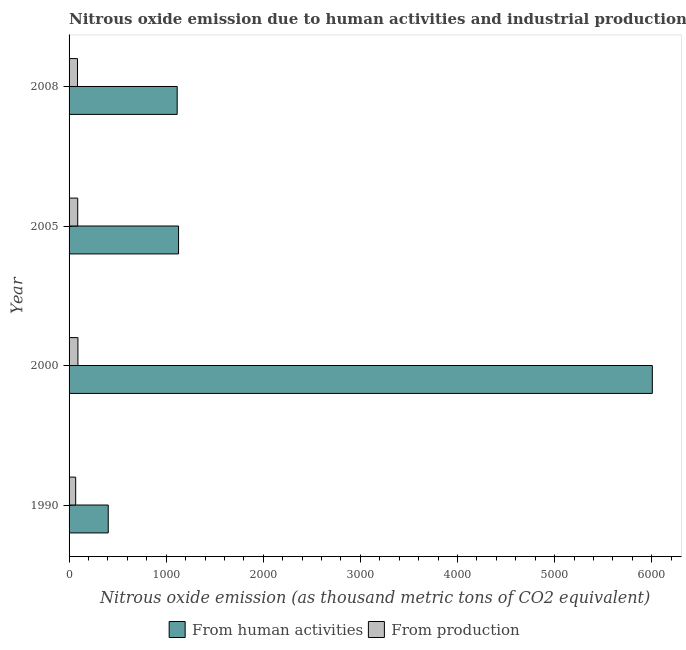How many different coloured bars are there?
Make the answer very short. 2. How many groups of bars are there?
Offer a very short reply. 4. Are the number of bars per tick equal to the number of legend labels?
Your response must be concise. Yes. How many bars are there on the 4th tick from the top?
Offer a very short reply. 2. How many bars are there on the 1st tick from the bottom?
Keep it short and to the point. 2. In how many cases, is the number of bars for a given year not equal to the number of legend labels?
Ensure brevity in your answer.  0. What is the amount of emissions from human activities in 2000?
Your answer should be compact. 6006.7. Across all years, what is the maximum amount of emissions generated from industries?
Your answer should be very brief. 91.1. Across all years, what is the minimum amount of emissions from human activities?
Offer a very short reply. 403.4. In which year was the amount of emissions from human activities minimum?
Keep it short and to the point. 1990. What is the total amount of emissions from human activities in the graph?
Ensure brevity in your answer.  8651.1. What is the difference between the amount of emissions generated from industries in 1990 and that in 2000?
Provide a succinct answer. -23.2. What is the difference between the amount of emissions from human activities in 2005 and the amount of emissions generated from industries in 2008?
Your answer should be compact. 1040.6. What is the average amount of emissions generated from industries per year?
Provide a short and direct response. 83.72. In the year 2008, what is the difference between the amount of emissions from human activities and amount of emissions generated from industries?
Provide a succinct answer. 1026.6. In how many years, is the amount of emissions from human activities greater than 3200 thousand metric tons?
Provide a short and direct response. 1. What is the ratio of the amount of emissions generated from industries in 1990 to that in 2005?
Make the answer very short. 0.76. Is the difference between the amount of emissions generated from industries in 1990 and 2005 greater than the difference between the amount of emissions from human activities in 1990 and 2005?
Your response must be concise. Yes. What is the difference between the highest and the second highest amount of emissions from human activities?
Make the answer very short. 4879.2. What is the difference between the highest and the lowest amount of emissions generated from industries?
Make the answer very short. 23.2. What does the 2nd bar from the top in 2000 represents?
Ensure brevity in your answer.  From human activities. What does the 2nd bar from the bottom in 2005 represents?
Your response must be concise. From production. How many bars are there?
Give a very brief answer. 8. What is the difference between two consecutive major ticks on the X-axis?
Offer a terse response. 1000. Are the values on the major ticks of X-axis written in scientific E-notation?
Offer a very short reply. No. Does the graph contain any zero values?
Ensure brevity in your answer.  No. How many legend labels are there?
Ensure brevity in your answer.  2. How are the legend labels stacked?
Your answer should be compact. Horizontal. What is the title of the graph?
Give a very brief answer. Nitrous oxide emission due to human activities and industrial production in Singapore. What is the label or title of the X-axis?
Your answer should be compact. Nitrous oxide emission (as thousand metric tons of CO2 equivalent). What is the Nitrous oxide emission (as thousand metric tons of CO2 equivalent) of From human activities in 1990?
Offer a very short reply. 403.4. What is the Nitrous oxide emission (as thousand metric tons of CO2 equivalent) of From production in 1990?
Your response must be concise. 67.9. What is the Nitrous oxide emission (as thousand metric tons of CO2 equivalent) of From human activities in 2000?
Keep it short and to the point. 6006.7. What is the Nitrous oxide emission (as thousand metric tons of CO2 equivalent) in From production in 2000?
Ensure brevity in your answer.  91.1. What is the Nitrous oxide emission (as thousand metric tons of CO2 equivalent) in From human activities in 2005?
Offer a terse response. 1127.5. What is the Nitrous oxide emission (as thousand metric tons of CO2 equivalent) in From production in 2005?
Your answer should be compact. 89. What is the Nitrous oxide emission (as thousand metric tons of CO2 equivalent) of From human activities in 2008?
Make the answer very short. 1113.5. What is the Nitrous oxide emission (as thousand metric tons of CO2 equivalent) of From production in 2008?
Give a very brief answer. 86.9. Across all years, what is the maximum Nitrous oxide emission (as thousand metric tons of CO2 equivalent) of From human activities?
Make the answer very short. 6006.7. Across all years, what is the maximum Nitrous oxide emission (as thousand metric tons of CO2 equivalent) in From production?
Provide a short and direct response. 91.1. Across all years, what is the minimum Nitrous oxide emission (as thousand metric tons of CO2 equivalent) in From human activities?
Offer a very short reply. 403.4. Across all years, what is the minimum Nitrous oxide emission (as thousand metric tons of CO2 equivalent) of From production?
Keep it short and to the point. 67.9. What is the total Nitrous oxide emission (as thousand metric tons of CO2 equivalent) of From human activities in the graph?
Keep it short and to the point. 8651.1. What is the total Nitrous oxide emission (as thousand metric tons of CO2 equivalent) in From production in the graph?
Offer a terse response. 334.9. What is the difference between the Nitrous oxide emission (as thousand metric tons of CO2 equivalent) in From human activities in 1990 and that in 2000?
Your answer should be compact. -5603.3. What is the difference between the Nitrous oxide emission (as thousand metric tons of CO2 equivalent) in From production in 1990 and that in 2000?
Provide a succinct answer. -23.2. What is the difference between the Nitrous oxide emission (as thousand metric tons of CO2 equivalent) of From human activities in 1990 and that in 2005?
Your answer should be very brief. -724.1. What is the difference between the Nitrous oxide emission (as thousand metric tons of CO2 equivalent) of From production in 1990 and that in 2005?
Provide a short and direct response. -21.1. What is the difference between the Nitrous oxide emission (as thousand metric tons of CO2 equivalent) of From human activities in 1990 and that in 2008?
Offer a terse response. -710.1. What is the difference between the Nitrous oxide emission (as thousand metric tons of CO2 equivalent) of From human activities in 2000 and that in 2005?
Provide a short and direct response. 4879.2. What is the difference between the Nitrous oxide emission (as thousand metric tons of CO2 equivalent) in From production in 2000 and that in 2005?
Give a very brief answer. 2.1. What is the difference between the Nitrous oxide emission (as thousand metric tons of CO2 equivalent) in From human activities in 2000 and that in 2008?
Ensure brevity in your answer.  4893.2. What is the difference between the Nitrous oxide emission (as thousand metric tons of CO2 equivalent) in From production in 2000 and that in 2008?
Provide a short and direct response. 4.2. What is the difference between the Nitrous oxide emission (as thousand metric tons of CO2 equivalent) of From human activities in 2005 and that in 2008?
Ensure brevity in your answer.  14. What is the difference between the Nitrous oxide emission (as thousand metric tons of CO2 equivalent) of From human activities in 1990 and the Nitrous oxide emission (as thousand metric tons of CO2 equivalent) of From production in 2000?
Make the answer very short. 312.3. What is the difference between the Nitrous oxide emission (as thousand metric tons of CO2 equivalent) in From human activities in 1990 and the Nitrous oxide emission (as thousand metric tons of CO2 equivalent) in From production in 2005?
Make the answer very short. 314.4. What is the difference between the Nitrous oxide emission (as thousand metric tons of CO2 equivalent) of From human activities in 1990 and the Nitrous oxide emission (as thousand metric tons of CO2 equivalent) of From production in 2008?
Make the answer very short. 316.5. What is the difference between the Nitrous oxide emission (as thousand metric tons of CO2 equivalent) in From human activities in 2000 and the Nitrous oxide emission (as thousand metric tons of CO2 equivalent) in From production in 2005?
Your answer should be very brief. 5917.7. What is the difference between the Nitrous oxide emission (as thousand metric tons of CO2 equivalent) in From human activities in 2000 and the Nitrous oxide emission (as thousand metric tons of CO2 equivalent) in From production in 2008?
Give a very brief answer. 5919.8. What is the difference between the Nitrous oxide emission (as thousand metric tons of CO2 equivalent) in From human activities in 2005 and the Nitrous oxide emission (as thousand metric tons of CO2 equivalent) in From production in 2008?
Your response must be concise. 1040.6. What is the average Nitrous oxide emission (as thousand metric tons of CO2 equivalent) in From human activities per year?
Your response must be concise. 2162.78. What is the average Nitrous oxide emission (as thousand metric tons of CO2 equivalent) of From production per year?
Your response must be concise. 83.72. In the year 1990, what is the difference between the Nitrous oxide emission (as thousand metric tons of CO2 equivalent) of From human activities and Nitrous oxide emission (as thousand metric tons of CO2 equivalent) of From production?
Offer a very short reply. 335.5. In the year 2000, what is the difference between the Nitrous oxide emission (as thousand metric tons of CO2 equivalent) of From human activities and Nitrous oxide emission (as thousand metric tons of CO2 equivalent) of From production?
Your answer should be very brief. 5915.6. In the year 2005, what is the difference between the Nitrous oxide emission (as thousand metric tons of CO2 equivalent) in From human activities and Nitrous oxide emission (as thousand metric tons of CO2 equivalent) in From production?
Provide a short and direct response. 1038.5. In the year 2008, what is the difference between the Nitrous oxide emission (as thousand metric tons of CO2 equivalent) in From human activities and Nitrous oxide emission (as thousand metric tons of CO2 equivalent) in From production?
Offer a terse response. 1026.6. What is the ratio of the Nitrous oxide emission (as thousand metric tons of CO2 equivalent) of From human activities in 1990 to that in 2000?
Offer a terse response. 0.07. What is the ratio of the Nitrous oxide emission (as thousand metric tons of CO2 equivalent) in From production in 1990 to that in 2000?
Offer a very short reply. 0.75. What is the ratio of the Nitrous oxide emission (as thousand metric tons of CO2 equivalent) of From human activities in 1990 to that in 2005?
Give a very brief answer. 0.36. What is the ratio of the Nitrous oxide emission (as thousand metric tons of CO2 equivalent) in From production in 1990 to that in 2005?
Offer a terse response. 0.76. What is the ratio of the Nitrous oxide emission (as thousand metric tons of CO2 equivalent) in From human activities in 1990 to that in 2008?
Provide a succinct answer. 0.36. What is the ratio of the Nitrous oxide emission (as thousand metric tons of CO2 equivalent) in From production in 1990 to that in 2008?
Your answer should be compact. 0.78. What is the ratio of the Nitrous oxide emission (as thousand metric tons of CO2 equivalent) of From human activities in 2000 to that in 2005?
Offer a very short reply. 5.33. What is the ratio of the Nitrous oxide emission (as thousand metric tons of CO2 equivalent) of From production in 2000 to that in 2005?
Offer a terse response. 1.02. What is the ratio of the Nitrous oxide emission (as thousand metric tons of CO2 equivalent) of From human activities in 2000 to that in 2008?
Your answer should be compact. 5.39. What is the ratio of the Nitrous oxide emission (as thousand metric tons of CO2 equivalent) of From production in 2000 to that in 2008?
Offer a very short reply. 1.05. What is the ratio of the Nitrous oxide emission (as thousand metric tons of CO2 equivalent) of From human activities in 2005 to that in 2008?
Your answer should be compact. 1.01. What is the ratio of the Nitrous oxide emission (as thousand metric tons of CO2 equivalent) of From production in 2005 to that in 2008?
Offer a terse response. 1.02. What is the difference between the highest and the second highest Nitrous oxide emission (as thousand metric tons of CO2 equivalent) in From human activities?
Provide a short and direct response. 4879.2. What is the difference between the highest and the lowest Nitrous oxide emission (as thousand metric tons of CO2 equivalent) of From human activities?
Your answer should be compact. 5603.3. What is the difference between the highest and the lowest Nitrous oxide emission (as thousand metric tons of CO2 equivalent) in From production?
Offer a terse response. 23.2. 